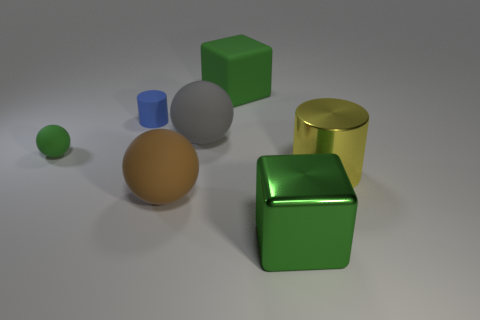Is the number of small blue cylinders that are in front of the big green shiny cube less than the number of blue rubber cylinders?
Give a very brief answer. Yes. There is a ball that is the same size as the blue thing; what color is it?
Provide a succinct answer. Green. How many other small blue rubber things are the same shape as the tiny blue matte thing?
Your response must be concise. 0. There is a large matte ball that is behind the yellow metallic cylinder; what color is it?
Give a very brief answer. Gray. What number of rubber things are either yellow cylinders or purple cubes?
Give a very brief answer. 0. There is a tiny thing that is the same color as the big matte block; what shape is it?
Provide a succinct answer. Sphere. How many green shiny balls are the same size as the rubber cylinder?
Your answer should be compact. 0. What is the color of the large thing that is both behind the green metal cube and in front of the yellow thing?
Provide a succinct answer. Brown. How many things are either big cyan objects or tiny blue rubber things?
Your answer should be compact. 1. How many tiny objects are yellow shiny balls or green rubber cubes?
Ensure brevity in your answer.  0. 